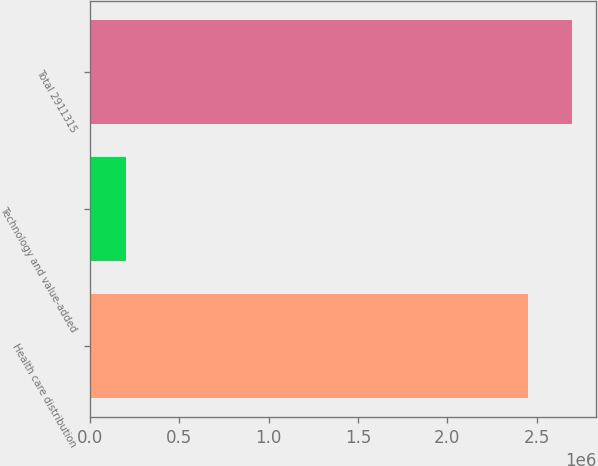<chart> <loc_0><loc_0><loc_500><loc_500><bar_chart><fcel>Health care distribution<fcel>Technology and value-added<fcel>Total 2911315<nl><fcel>2.45133e+06<fcel>204680<fcel>2.69647e+06<nl></chart> 